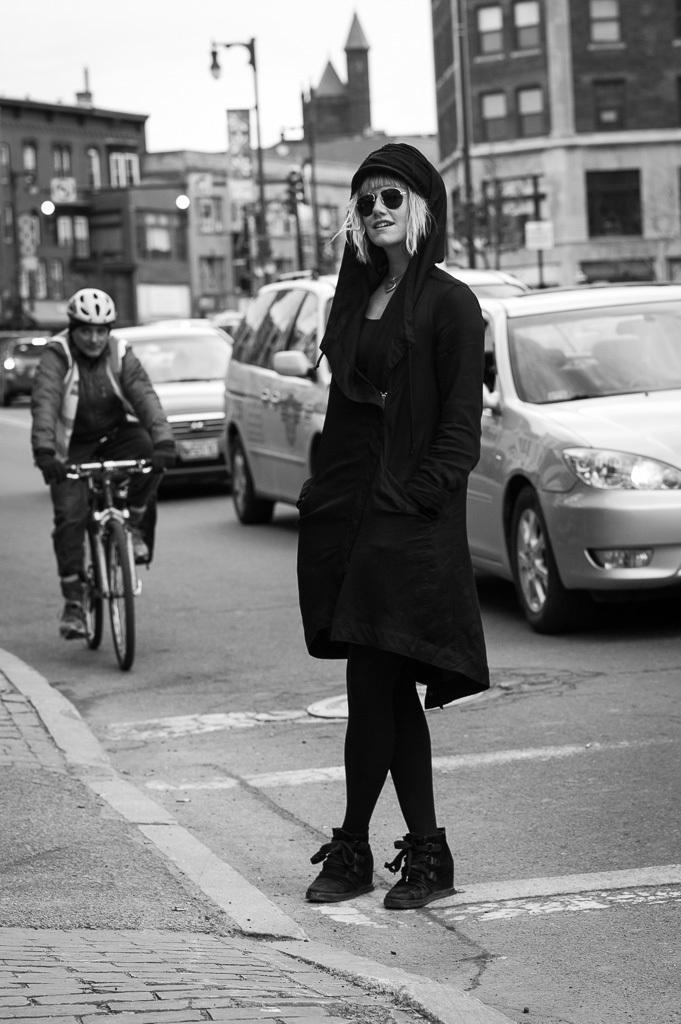Can you describe this image briefly? This image is taken in outdoors. In the middle of the image a woman is standing on the road and a man is riding a bicycle wearing a helmet. At the background there are few vehicles, a street light and a buildings with windows and doors. 